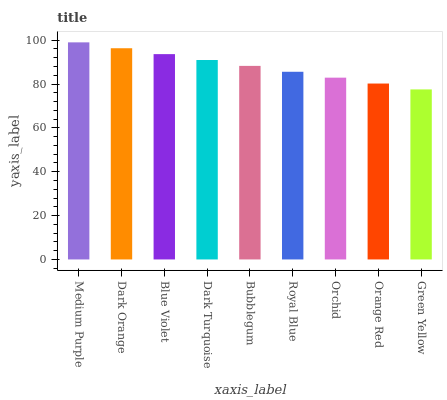Is Green Yellow the minimum?
Answer yes or no. Yes. Is Medium Purple the maximum?
Answer yes or no. Yes. Is Dark Orange the minimum?
Answer yes or no. No. Is Dark Orange the maximum?
Answer yes or no. No. Is Medium Purple greater than Dark Orange?
Answer yes or no. Yes. Is Dark Orange less than Medium Purple?
Answer yes or no. Yes. Is Dark Orange greater than Medium Purple?
Answer yes or no. No. Is Medium Purple less than Dark Orange?
Answer yes or no. No. Is Bubblegum the high median?
Answer yes or no. Yes. Is Bubblegum the low median?
Answer yes or no. Yes. Is Dark Orange the high median?
Answer yes or no. No. Is Dark Orange the low median?
Answer yes or no. No. 